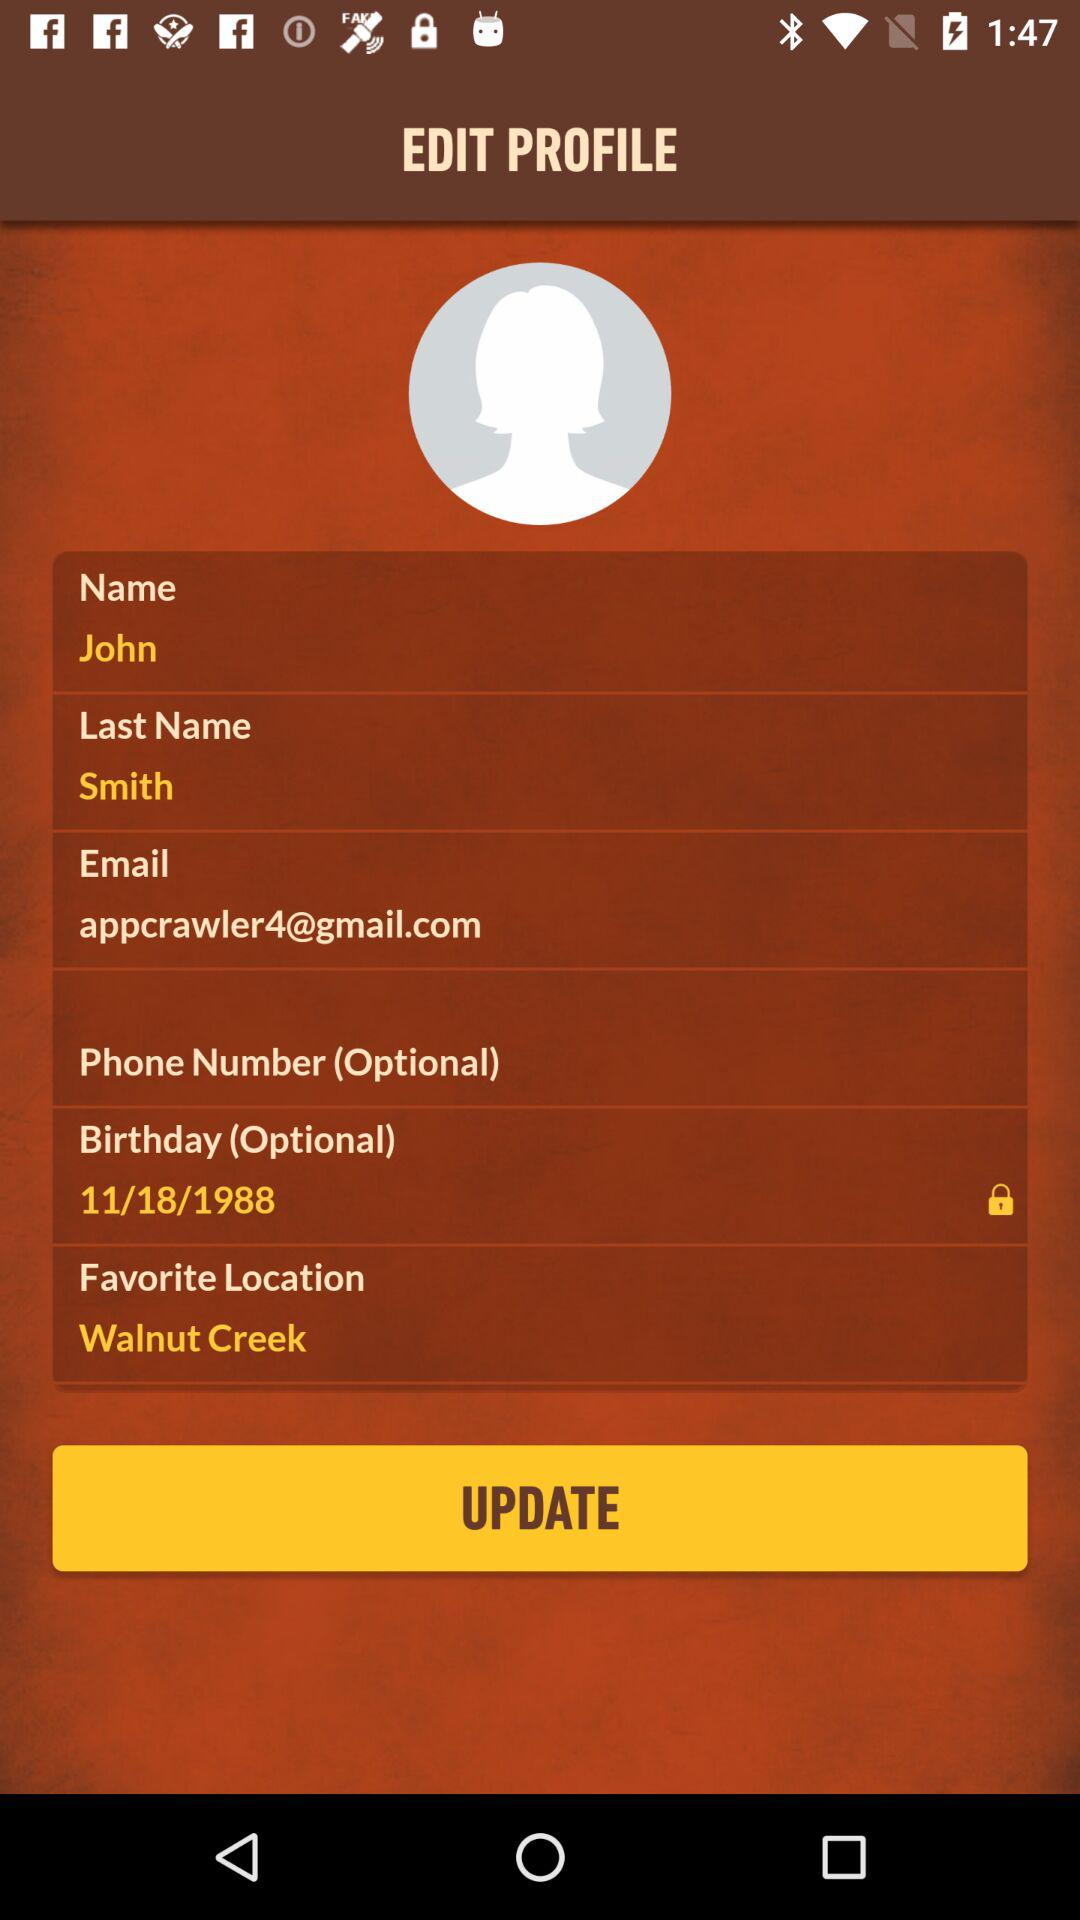What is the date of birth? The date of birth is November 18, 1988. 